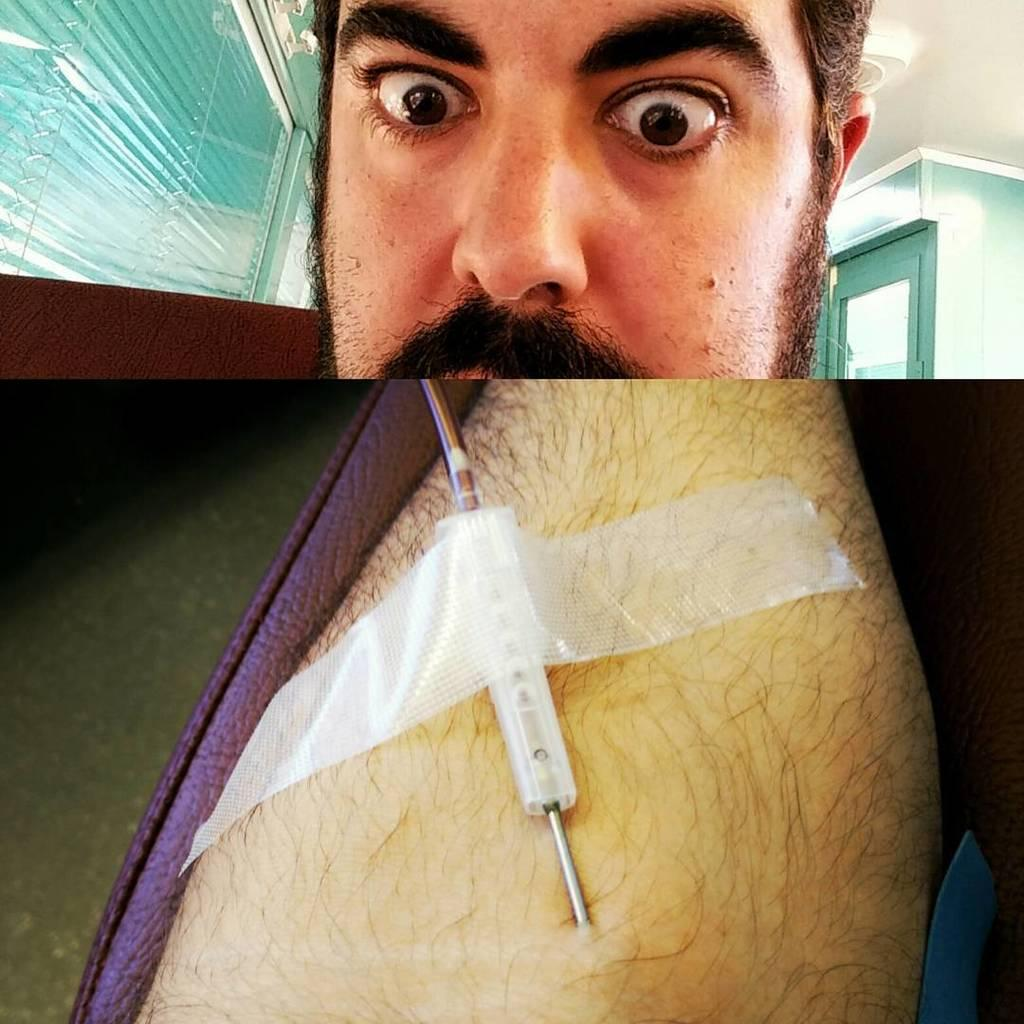What is the main subject of the image? The image contains a collage of pictures. Can you describe any specific pictures within the collage? Yes, there is a picture with a person and another picture with a needle on a hand. What is the needle doing in the picture? The needle is stuck with a tape in the picture. What architectural features can be seen in the background of the image? There are group of windows and a door in the background of the image. How many cows are present in the image? There are no cows present in the image; it contains a collage of pictures with a person and a needle with tape. What type of school is depicted in the image? There is no school depicted in the image; it contains a collage of pictures with a person and a needle with tape. 